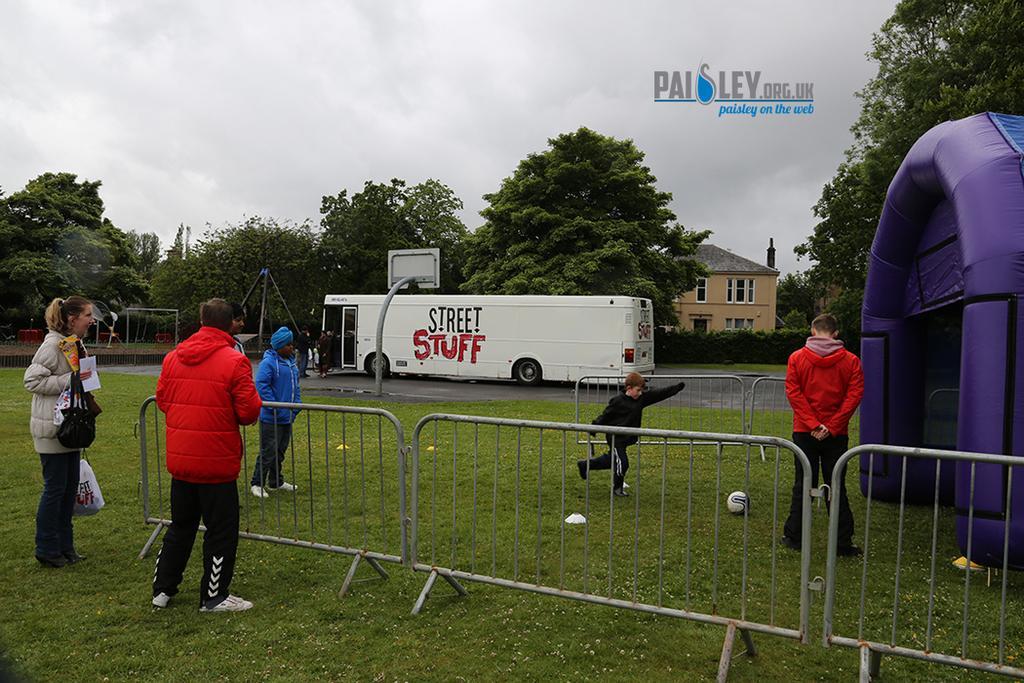How would you summarize this image in a sentence or two? In the center of the image we can see a few people are standing and they are wearing jackets. Among them, we can see one woman holding some objects. And we can see one ball, tent, fences and grass. In the background, we can see the sky, clouds, trees, poles, one building, windows, one vehicle, play area, few people are standing, road and a few other objects. 